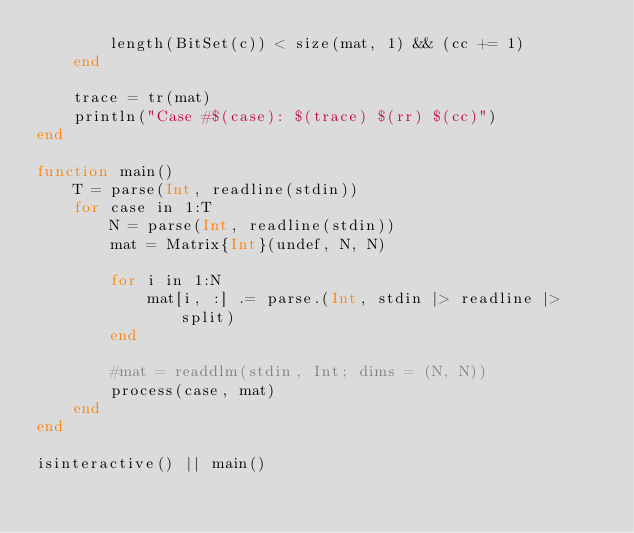<code> <loc_0><loc_0><loc_500><loc_500><_Julia_>        length(BitSet(c)) < size(mat, 1) && (cc += 1)
    end

    trace = tr(mat)
    println("Case #$(case): $(trace) $(rr) $(cc)")
end

function main()
    T = parse(Int, readline(stdin))
    for case in 1:T
        N = parse(Int, readline(stdin))
        mat = Matrix{Int}(undef, N, N)

        for i in 1:N
            mat[i, :] .= parse.(Int, stdin |> readline |> split)
        end

        #mat = readdlm(stdin, Int; dims = (N, N))
        process(case, mat)
    end
end

isinteractive() || main()
</code> 